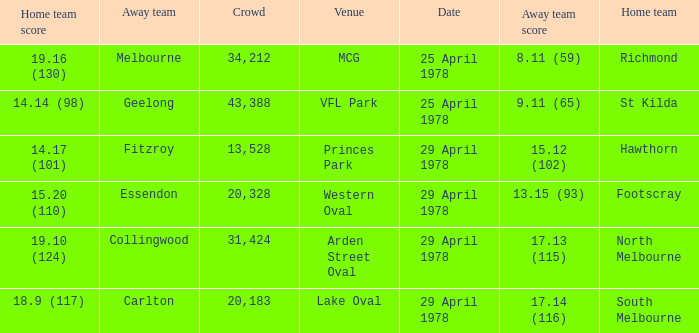Who was the home team at MCG? Richmond. 